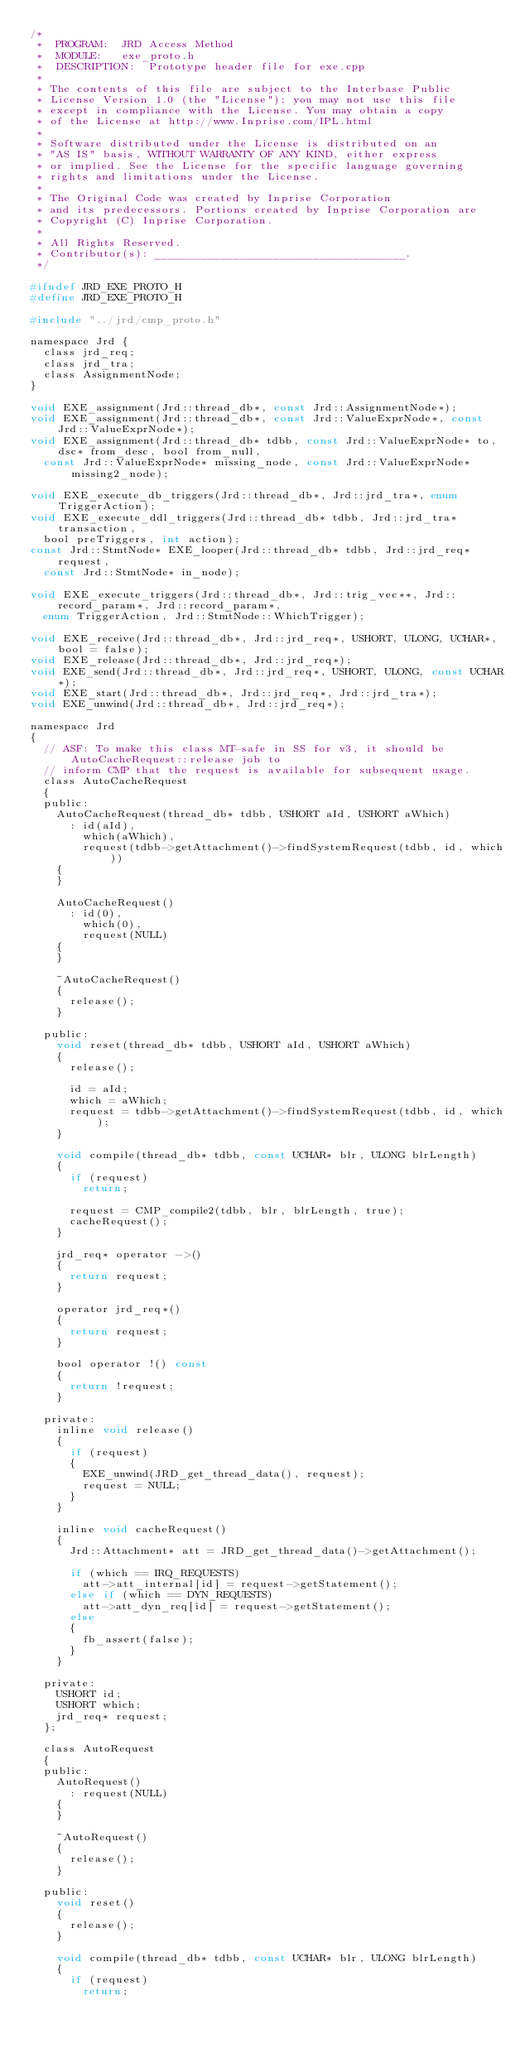<code> <loc_0><loc_0><loc_500><loc_500><_C_>/*
 *	PROGRAM:	JRD Access Method
 *	MODULE:		exe_proto.h
 *	DESCRIPTION:	Prototype header file for exe.cpp
 *
 * The contents of this file are subject to the Interbase Public
 * License Version 1.0 (the "License"); you may not use this file
 * except in compliance with the License. You may obtain a copy
 * of the License at http://www.Inprise.com/IPL.html
 *
 * Software distributed under the License is distributed on an
 * "AS IS" basis, WITHOUT WARRANTY OF ANY KIND, either express
 * or implied. See the License for the specific language governing
 * rights and limitations under the License.
 *
 * The Original Code was created by Inprise Corporation
 * and its predecessors. Portions created by Inprise Corporation are
 * Copyright (C) Inprise Corporation.
 *
 * All Rights Reserved.
 * Contributor(s): ______________________________________.
 */

#ifndef JRD_EXE_PROTO_H
#define JRD_EXE_PROTO_H

#include "../jrd/cmp_proto.h"

namespace Jrd {
	class jrd_req;
	class jrd_tra;
	class AssignmentNode;
}

void EXE_assignment(Jrd::thread_db*, const Jrd::AssignmentNode*);
void EXE_assignment(Jrd::thread_db*, const Jrd::ValueExprNode*, const Jrd::ValueExprNode*);
void EXE_assignment(Jrd::thread_db* tdbb, const Jrd::ValueExprNode* to, dsc* from_desc, bool from_null,
	const Jrd::ValueExprNode* missing_node, const Jrd::ValueExprNode* missing2_node);

void EXE_execute_db_triggers(Jrd::thread_db*, Jrd::jrd_tra*, enum TriggerAction);
void EXE_execute_ddl_triggers(Jrd::thread_db* tdbb, Jrd::jrd_tra* transaction,
	bool preTriggers, int action);
const Jrd::StmtNode* EXE_looper(Jrd::thread_db* tdbb, Jrd::jrd_req* request,
	const Jrd::StmtNode* in_node);

void EXE_execute_triggers(Jrd::thread_db*, Jrd::trig_vec**, Jrd::record_param*, Jrd::record_param*,
	enum TriggerAction, Jrd::StmtNode::WhichTrigger);

void EXE_receive(Jrd::thread_db*, Jrd::jrd_req*, USHORT, ULONG, UCHAR*, bool = false);
void EXE_release(Jrd::thread_db*, Jrd::jrd_req*);
void EXE_send(Jrd::thread_db*, Jrd::jrd_req*, USHORT, ULONG, const UCHAR*);
void EXE_start(Jrd::thread_db*, Jrd::jrd_req*, Jrd::jrd_tra*);
void EXE_unwind(Jrd::thread_db*, Jrd::jrd_req*);

namespace Jrd
{
	// ASF: To make this class MT-safe in SS for v3, it should be AutoCacheRequest::release job to
	// inform CMP that the request is available for subsequent usage.
	class AutoCacheRequest
	{
	public:
		AutoCacheRequest(thread_db* tdbb, USHORT aId, USHORT aWhich)
			: id(aId),
			  which(aWhich),
			  request(tdbb->getAttachment()->findSystemRequest(tdbb, id, which))
		{
		}

		AutoCacheRequest()
			: id(0),
			  which(0),
			  request(NULL)
		{
		}

		~AutoCacheRequest()
		{
			release();
		}

	public:
		void reset(thread_db* tdbb, USHORT aId, USHORT aWhich)
		{
			release();

			id = aId;
			which = aWhich;
			request = tdbb->getAttachment()->findSystemRequest(tdbb, id, which);
		}

		void compile(thread_db* tdbb, const UCHAR* blr, ULONG blrLength)
		{
			if (request)
				return;

			request = CMP_compile2(tdbb, blr, blrLength, true);
			cacheRequest();
		}

		jrd_req* operator ->()
		{
			return request;
		}

		operator jrd_req*()
		{
			return request;
		}

		bool operator !() const
		{
			return !request;
		}

	private:
		inline void release()
		{
			if (request)
			{
				EXE_unwind(JRD_get_thread_data(), request);
				request = NULL;
			}
		}

		inline void cacheRequest()
		{
			Jrd::Attachment* att = JRD_get_thread_data()->getAttachment();

			if (which == IRQ_REQUESTS)
				att->att_internal[id] = request->getStatement();
			else if (which == DYN_REQUESTS)
				att->att_dyn_req[id] = request->getStatement();
			else
			{
				fb_assert(false);
			}
		}

	private:
		USHORT id;
		USHORT which;
		jrd_req* request;
	};

	class AutoRequest
	{
	public:
		AutoRequest()
			: request(NULL)
		{
		}

		~AutoRequest()
		{
			release();
		}

	public:
		void reset()
		{
			release();
		}

		void compile(thread_db* tdbb, const UCHAR* blr, ULONG blrLength)
		{
			if (request)
				return;
</code> 